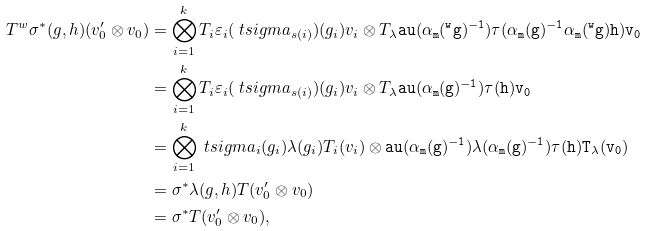Convert formula to latex. <formula><loc_0><loc_0><loc_500><loc_500>T { ^ { w } } \sigma ^ { * } ( g , h ) ( v ^ { \prime } _ { 0 } \otimes v _ { 0 } ) & = \bigotimes _ { i = 1 } ^ { k } T _ { i } \varepsilon _ { i } ( \ t s i g m a _ { s ( i ) } ) ( g _ { i } ) v _ { i } \otimes T _ { \lambda } \tt a u ( \alpha _ { m } ( { ^ { w } } g ) ^ { - 1 } ) \tau ( \alpha _ { m } ( g ) ^ { - 1 } \alpha _ { m } ( { ^ { w } } g ) h ) v _ { 0 } \\ & = \bigotimes _ { i = 1 } ^ { k } T _ { i } \varepsilon _ { i } ( \ t s i g m a _ { s ( i ) } ) ( g _ { i } ) v _ { i } \otimes T _ { \lambda } \tt a u ( \alpha _ { m } ( g ) ^ { - 1 } ) \tau ( h ) v _ { 0 } \\ & = \bigotimes _ { i = 1 } ^ { k } \ t s i g m a _ { i } ( g _ { i } ) \lambda ( g _ { i } ) T _ { i } ( v _ { i } ) \otimes \tt a u ( \alpha _ { m } ( g ) ^ { - 1 } ) \lambda ( \alpha _ { m } ( g ) ^ { - 1 } ) \tau ( h ) T _ { \lambda } ( v _ { 0 } ) \\ & = \sigma ^ { * } \lambda ( g , h ) T ( v _ { 0 } ^ { \prime } \otimes v _ { 0 } ) \\ & = \sigma ^ { * } T ( v _ { 0 } ^ { \prime } \otimes v _ { 0 } ) ,</formula> 